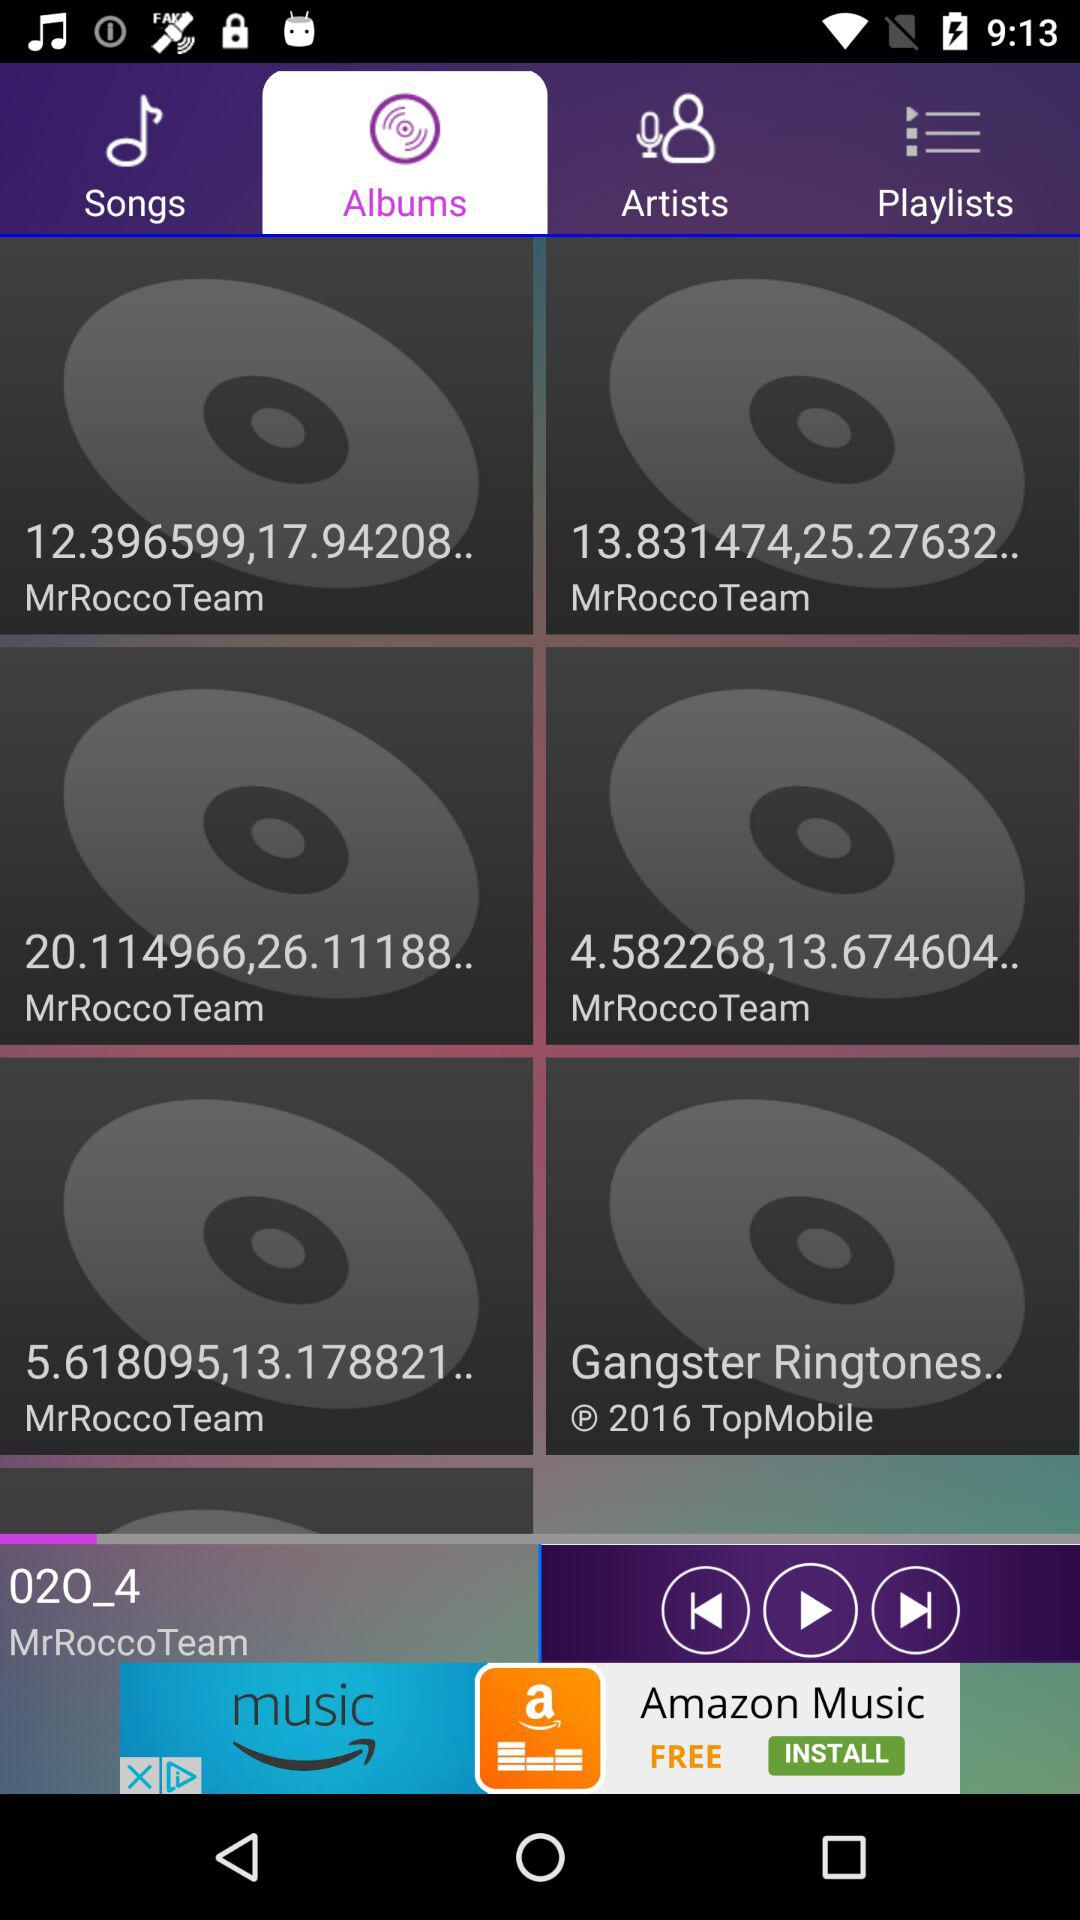Which album is playing? The album is 02O_4. 